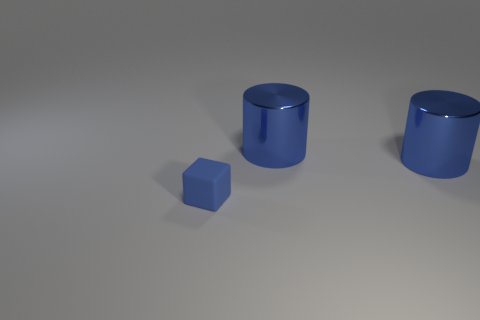How many objects are things that are on the right side of the small blue rubber cube or things to the right of the small matte block?
Make the answer very short. 2. Is the number of small objects in front of the small matte thing less than the number of gray spheres?
Keep it short and to the point. No. Are there any cyan objects of the same size as the matte block?
Your answer should be very brief. No. What is the color of the tiny rubber cube?
Keep it short and to the point. Blue. How many things are tiny blue matte objects or big blue shiny cylinders?
Your answer should be very brief. 3. Are there the same number of cubes in front of the small blue rubber cube and shiny objects?
Offer a very short reply. No. What number of balls are either small brown shiny objects or small blue rubber objects?
Give a very brief answer. 0. What is the shape of the small blue rubber object?
Provide a short and direct response. Cube. How many other things are made of the same material as the small object?
Provide a short and direct response. 0. What number of other things are the same color as the matte block?
Make the answer very short. 2. 